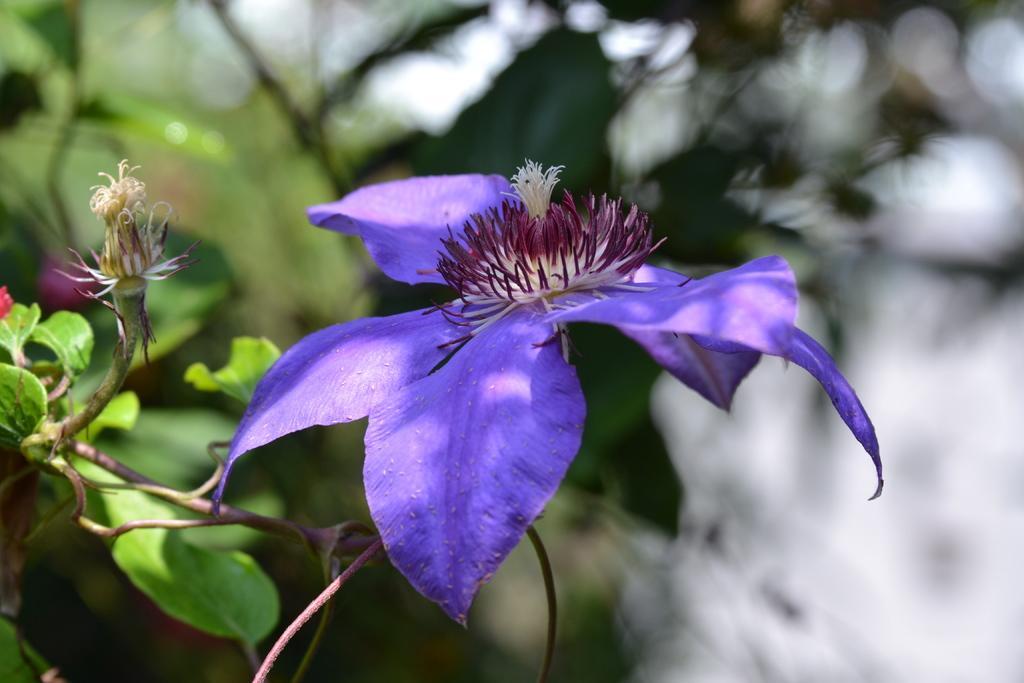Describe this image in one or two sentences. In this image there are flowers and plants. 